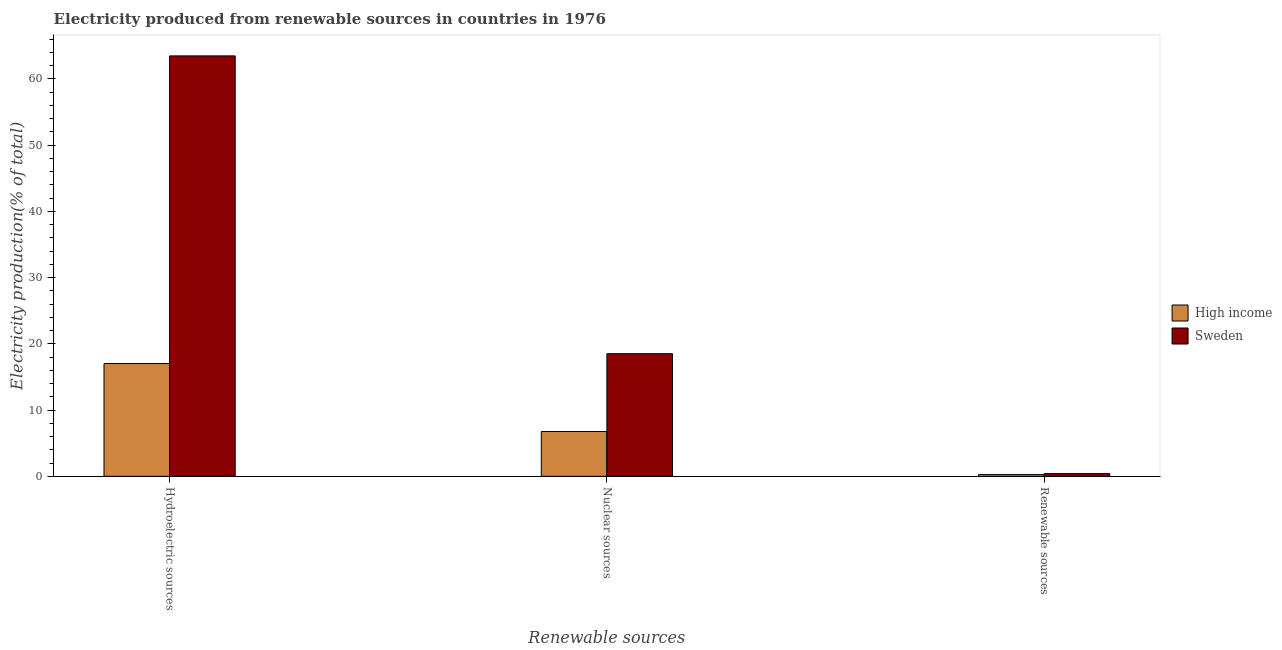How many different coloured bars are there?
Your response must be concise. 2. Are the number of bars per tick equal to the number of legend labels?
Keep it short and to the point. Yes. How many bars are there on the 3rd tick from the right?
Provide a short and direct response. 2. What is the label of the 1st group of bars from the left?
Your response must be concise. Hydroelectric sources. What is the percentage of electricity produced by hydroelectric sources in Sweden?
Offer a terse response. 63.47. Across all countries, what is the maximum percentage of electricity produced by nuclear sources?
Make the answer very short. 18.51. Across all countries, what is the minimum percentage of electricity produced by hydroelectric sources?
Provide a short and direct response. 17.03. What is the total percentage of electricity produced by nuclear sources in the graph?
Your answer should be compact. 25.28. What is the difference between the percentage of electricity produced by hydroelectric sources in High income and that in Sweden?
Offer a very short reply. -46.44. What is the difference between the percentage of electricity produced by nuclear sources in Sweden and the percentage of electricity produced by hydroelectric sources in High income?
Provide a succinct answer. 1.48. What is the average percentage of electricity produced by hydroelectric sources per country?
Provide a short and direct response. 40.25. What is the difference between the percentage of electricity produced by hydroelectric sources and percentage of electricity produced by renewable sources in Sweden?
Provide a succinct answer. 63.06. In how many countries, is the percentage of electricity produced by nuclear sources greater than 58 %?
Make the answer very short. 0. What is the ratio of the percentage of electricity produced by hydroelectric sources in High income to that in Sweden?
Provide a succinct answer. 0.27. Is the percentage of electricity produced by renewable sources in High income less than that in Sweden?
Offer a very short reply. Yes. Is the difference between the percentage of electricity produced by hydroelectric sources in High income and Sweden greater than the difference between the percentage of electricity produced by nuclear sources in High income and Sweden?
Keep it short and to the point. No. What is the difference between the highest and the second highest percentage of electricity produced by nuclear sources?
Give a very brief answer. 11.75. What is the difference between the highest and the lowest percentage of electricity produced by hydroelectric sources?
Provide a succinct answer. 46.44. Is the sum of the percentage of electricity produced by hydroelectric sources in Sweden and High income greater than the maximum percentage of electricity produced by nuclear sources across all countries?
Provide a succinct answer. Yes. What does the 2nd bar from the left in Hydroelectric sources represents?
Make the answer very short. Sweden. Are all the bars in the graph horizontal?
Offer a very short reply. No. What is the difference between two consecutive major ticks on the Y-axis?
Provide a short and direct response. 10. Are the values on the major ticks of Y-axis written in scientific E-notation?
Ensure brevity in your answer.  No. Does the graph contain any zero values?
Provide a short and direct response. No. Where does the legend appear in the graph?
Your answer should be compact. Center right. How many legend labels are there?
Keep it short and to the point. 2. How are the legend labels stacked?
Give a very brief answer. Vertical. What is the title of the graph?
Ensure brevity in your answer.  Electricity produced from renewable sources in countries in 1976. Does "Rwanda" appear as one of the legend labels in the graph?
Provide a succinct answer. No. What is the label or title of the X-axis?
Your response must be concise. Renewable sources. What is the Electricity production(% of total) of High income in Hydroelectric sources?
Give a very brief answer. 17.03. What is the Electricity production(% of total) of Sweden in Hydroelectric sources?
Offer a very short reply. 63.47. What is the Electricity production(% of total) of High income in Nuclear sources?
Your answer should be very brief. 6.77. What is the Electricity production(% of total) of Sweden in Nuclear sources?
Your response must be concise. 18.51. What is the Electricity production(% of total) of High income in Renewable sources?
Provide a short and direct response. 0.26. What is the Electricity production(% of total) of Sweden in Renewable sources?
Provide a succinct answer. 0.41. Across all Renewable sources, what is the maximum Electricity production(% of total) of High income?
Your answer should be compact. 17.03. Across all Renewable sources, what is the maximum Electricity production(% of total) of Sweden?
Offer a very short reply. 63.47. Across all Renewable sources, what is the minimum Electricity production(% of total) in High income?
Give a very brief answer. 0.26. Across all Renewable sources, what is the minimum Electricity production(% of total) in Sweden?
Your answer should be very brief. 0.41. What is the total Electricity production(% of total) in High income in the graph?
Give a very brief answer. 24.06. What is the total Electricity production(% of total) of Sweden in the graph?
Make the answer very short. 82.39. What is the difference between the Electricity production(% of total) of High income in Hydroelectric sources and that in Nuclear sources?
Your answer should be compact. 10.26. What is the difference between the Electricity production(% of total) in Sweden in Hydroelectric sources and that in Nuclear sources?
Your response must be concise. 44.96. What is the difference between the Electricity production(% of total) in High income in Hydroelectric sources and that in Renewable sources?
Offer a terse response. 16.77. What is the difference between the Electricity production(% of total) in Sweden in Hydroelectric sources and that in Renewable sources?
Provide a short and direct response. 63.06. What is the difference between the Electricity production(% of total) of High income in Nuclear sources and that in Renewable sources?
Your response must be concise. 6.5. What is the difference between the Electricity production(% of total) in Sweden in Nuclear sources and that in Renewable sources?
Your answer should be compact. 18.1. What is the difference between the Electricity production(% of total) of High income in Hydroelectric sources and the Electricity production(% of total) of Sweden in Nuclear sources?
Your response must be concise. -1.48. What is the difference between the Electricity production(% of total) of High income in Hydroelectric sources and the Electricity production(% of total) of Sweden in Renewable sources?
Offer a terse response. 16.62. What is the difference between the Electricity production(% of total) of High income in Nuclear sources and the Electricity production(% of total) of Sweden in Renewable sources?
Provide a succinct answer. 6.36. What is the average Electricity production(% of total) in High income per Renewable sources?
Provide a short and direct response. 8.02. What is the average Electricity production(% of total) of Sweden per Renewable sources?
Ensure brevity in your answer.  27.46. What is the difference between the Electricity production(% of total) in High income and Electricity production(% of total) in Sweden in Hydroelectric sources?
Provide a short and direct response. -46.44. What is the difference between the Electricity production(% of total) of High income and Electricity production(% of total) of Sweden in Nuclear sources?
Ensure brevity in your answer.  -11.75. What is the difference between the Electricity production(% of total) of High income and Electricity production(% of total) of Sweden in Renewable sources?
Your response must be concise. -0.15. What is the ratio of the Electricity production(% of total) of High income in Hydroelectric sources to that in Nuclear sources?
Keep it short and to the point. 2.52. What is the ratio of the Electricity production(% of total) in Sweden in Hydroelectric sources to that in Nuclear sources?
Make the answer very short. 3.43. What is the ratio of the Electricity production(% of total) of High income in Hydroelectric sources to that in Renewable sources?
Provide a short and direct response. 64.9. What is the ratio of the Electricity production(% of total) in Sweden in Hydroelectric sources to that in Renewable sources?
Your answer should be compact. 154.89. What is the ratio of the Electricity production(% of total) in High income in Nuclear sources to that in Renewable sources?
Your response must be concise. 25.79. What is the ratio of the Electricity production(% of total) in Sweden in Nuclear sources to that in Renewable sources?
Offer a very short reply. 45.18. What is the difference between the highest and the second highest Electricity production(% of total) of High income?
Offer a very short reply. 10.26. What is the difference between the highest and the second highest Electricity production(% of total) in Sweden?
Make the answer very short. 44.96. What is the difference between the highest and the lowest Electricity production(% of total) in High income?
Keep it short and to the point. 16.77. What is the difference between the highest and the lowest Electricity production(% of total) in Sweden?
Offer a very short reply. 63.06. 